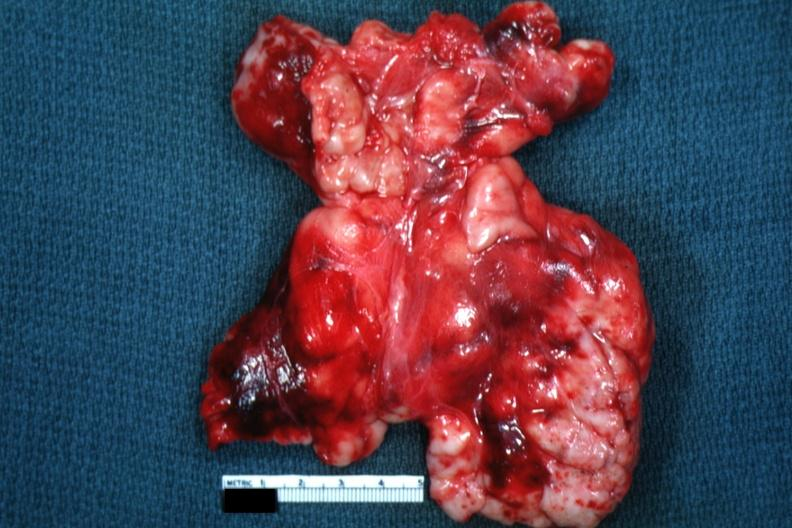s infarcts present?
Answer the question using a single word or phrase. No 